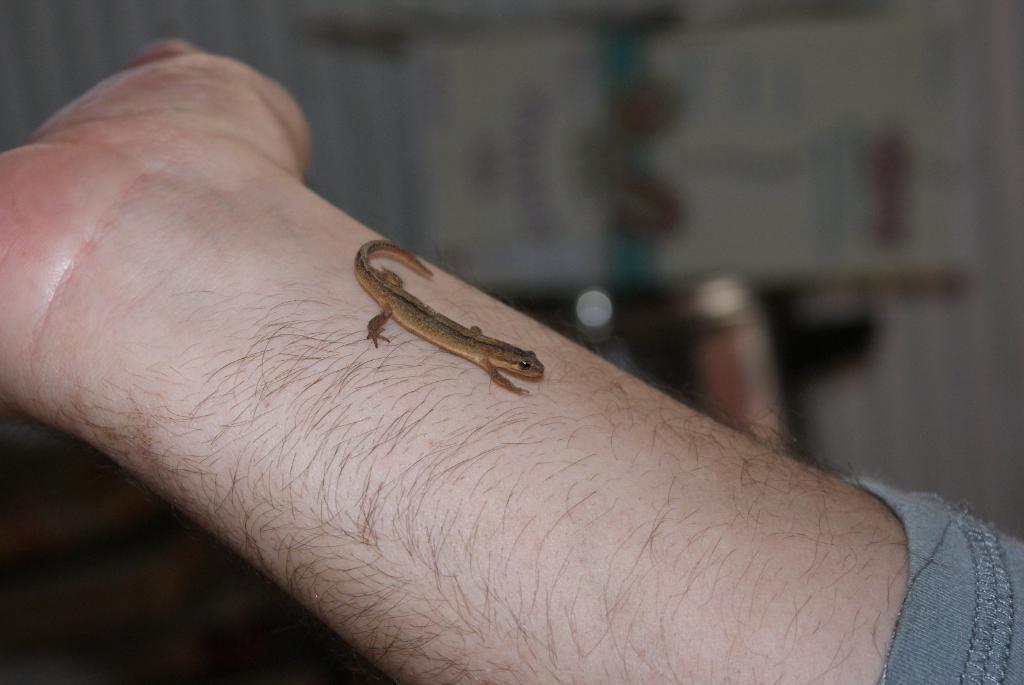Can you describe this image briefly? In this image, we can see a lizard on the person's hand. 